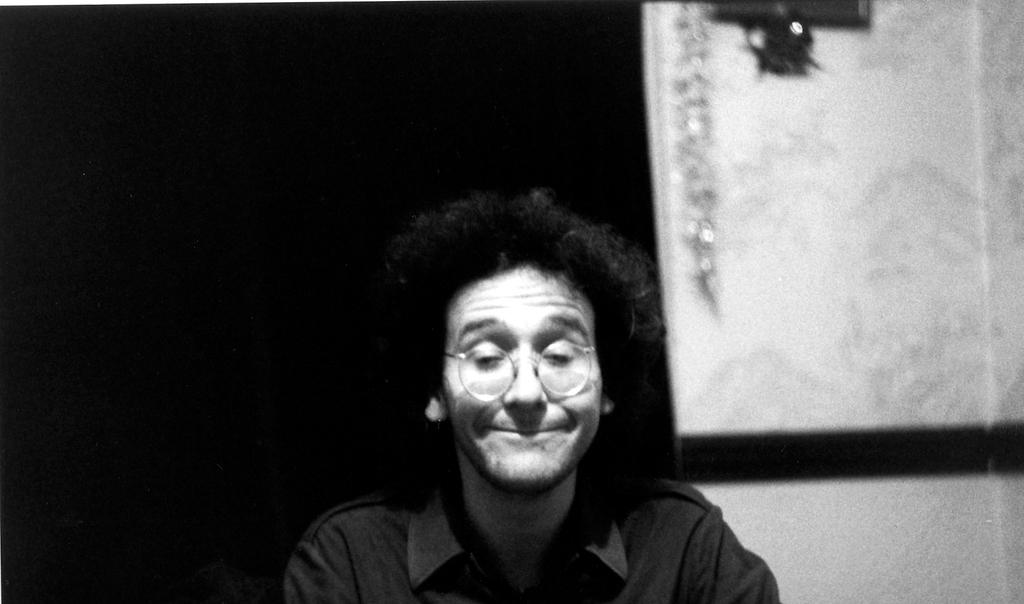What is the color scheme of the image? The image is black and white. Can you describe the main subject of the image? There is a person in the image. What type of paste is being used by the person in the image? There is no indication of any paste being used in the image, as it is a black and white image featuring a person. 